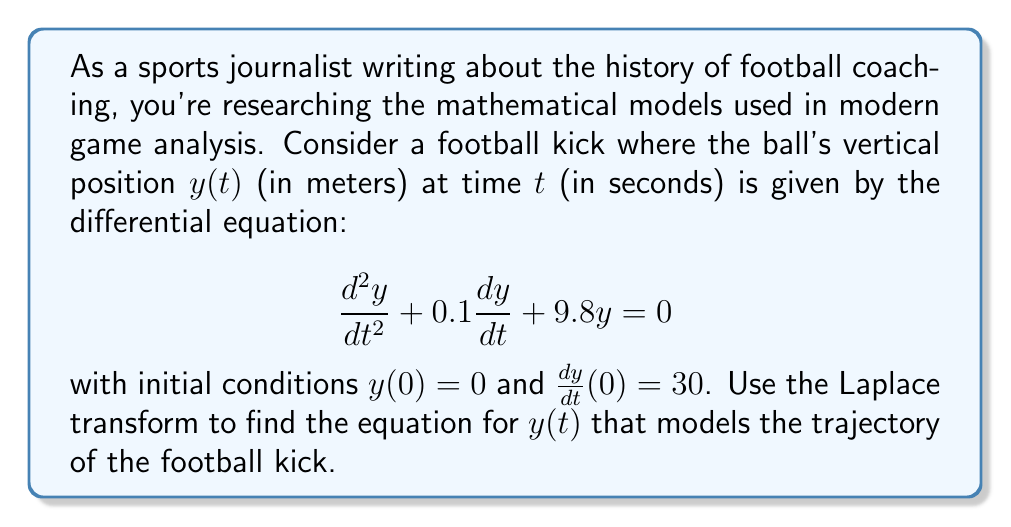Can you answer this question? Let's solve this step-by-step using the Laplace transform:

1) First, let's take the Laplace transform of both sides of the differential equation:

   $\mathcal{L}\{\frac{d^2y}{dt^2} + 0.1\frac{dy}{dt} + 9.8y\} = \mathcal{L}\{0\}$

2) Using the properties of the Laplace transform:

   $s^2Y(s) - sy(0) - y'(0) + 0.1[sY(s) - y(0)] + 9.8Y(s) = 0$

3) Substitute the initial conditions $y(0) = 0$ and $y'(0) = 30$:

   $s^2Y(s) - 30 + 0.1sY(s) + 9.8Y(s) = 0$

4) Factor out $Y(s)$:

   $Y(s)(s^2 + 0.1s + 9.8) = 30$

5) Solve for $Y(s)$:

   $Y(s) = \frac{30}{s^2 + 0.1s + 9.8}$

6) This can be rewritten as:

   $Y(s) = \frac{30}{(s + 0.05)^2 + 9.7975}$

7) This is in the form of the Laplace transform of a damped sinusoidal function:

   $\frac{A\omega}{(s + \alpha)^2 + \omega^2}$

   where $A = \frac{30}{\sqrt{9.7975}} \approx 9.5847$, $\alpha = 0.05$, and $\omega = \sqrt{9.7975} \approx 3.1301$

8) The inverse Laplace transform of this function is:

   $y(t) = Ae^{-\alpha t}\sin(\omega t)$

9) Substituting the values:

   $y(t) = 9.5847e^{-0.05t}\sin(3.1301t)$

This equation models the vertical position of the football over time, taking into account air resistance (represented by the damping term in the original differential equation).
Answer: $y(t) = 9.5847e^{-0.05t}\sin(3.1301t)$ meters 